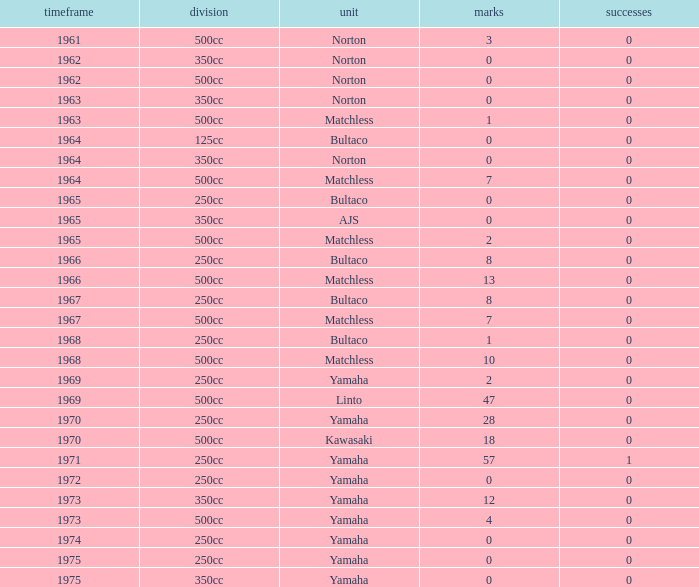Would you mind parsing the complete table? {'header': ['timeframe', 'division', 'unit', 'marks', 'successes'], 'rows': [['1961', '500cc', 'Norton', '3', '0'], ['1962', '350cc', 'Norton', '0', '0'], ['1962', '500cc', 'Norton', '0', '0'], ['1963', '350cc', 'Norton', '0', '0'], ['1963', '500cc', 'Matchless', '1', '0'], ['1964', '125cc', 'Bultaco', '0', '0'], ['1964', '350cc', 'Norton', '0', '0'], ['1964', '500cc', 'Matchless', '7', '0'], ['1965', '250cc', 'Bultaco', '0', '0'], ['1965', '350cc', 'AJS', '0', '0'], ['1965', '500cc', 'Matchless', '2', '0'], ['1966', '250cc', 'Bultaco', '8', '0'], ['1966', '500cc', 'Matchless', '13', '0'], ['1967', '250cc', 'Bultaco', '8', '0'], ['1967', '500cc', 'Matchless', '7', '0'], ['1968', '250cc', 'Bultaco', '1', '0'], ['1968', '500cc', 'Matchless', '10', '0'], ['1969', '250cc', 'Yamaha', '2', '0'], ['1969', '500cc', 'Linto', '47', '0'], ['1970', '250cc', 'Yamaha', '28', '0'], ['1970', '500cc', 'Kawasaki', '18', '0'], ['1971', '250cc', 'Yamaha', '57', '1'], ['1972', '250cc', 'Yamaha', '0', '0'], ['1973', '350cc', 'Yamaha', '12', '0'], ['1973', '500cc', 'Yamaha', '4', '0'], ['1974', '250cc', 'Yamaha', '0', '0'], ['1975', '250cc', 'Yamaha', '0', '0'], ['1975', '350cc', 'Yamaha', '0', '0']]} Which class corresponds to more than 2 points, wins greater than 0, and a year earlier than 1973? 250cc. 